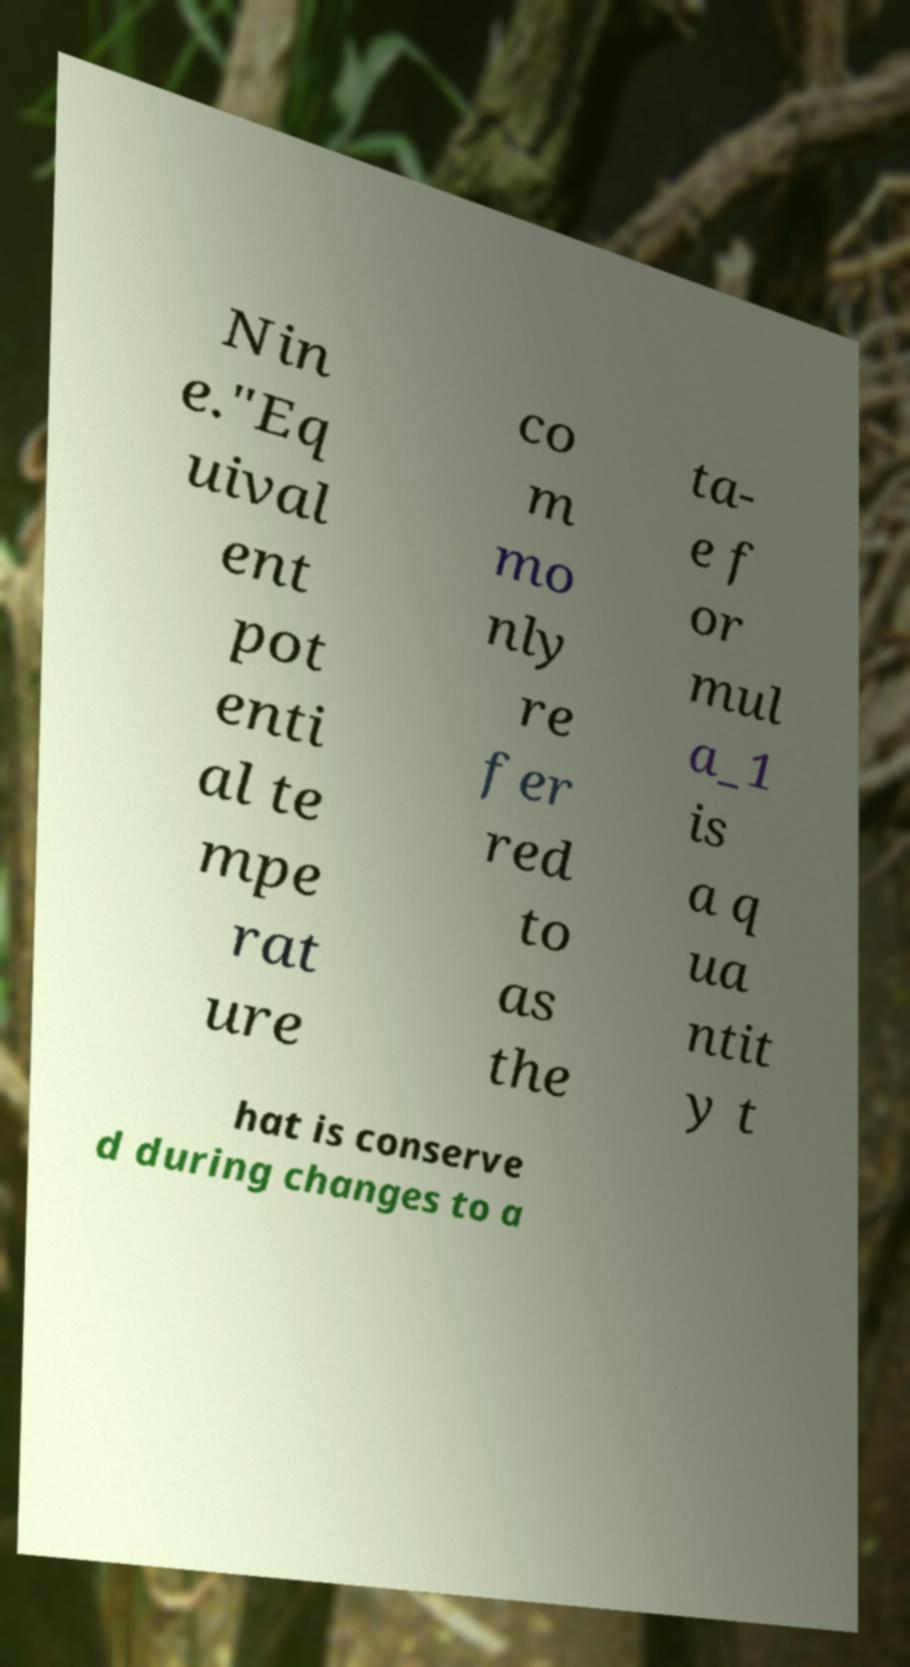What messages or text are displayed in this image? I need them in a readable, typed format. Nin e."Eq uival ent pot enti al te mpe rat ure co m mo nly re fer red to as the ta- e f or mul a_1 is a q ua ntit y t hat is conserve d during changes to a 